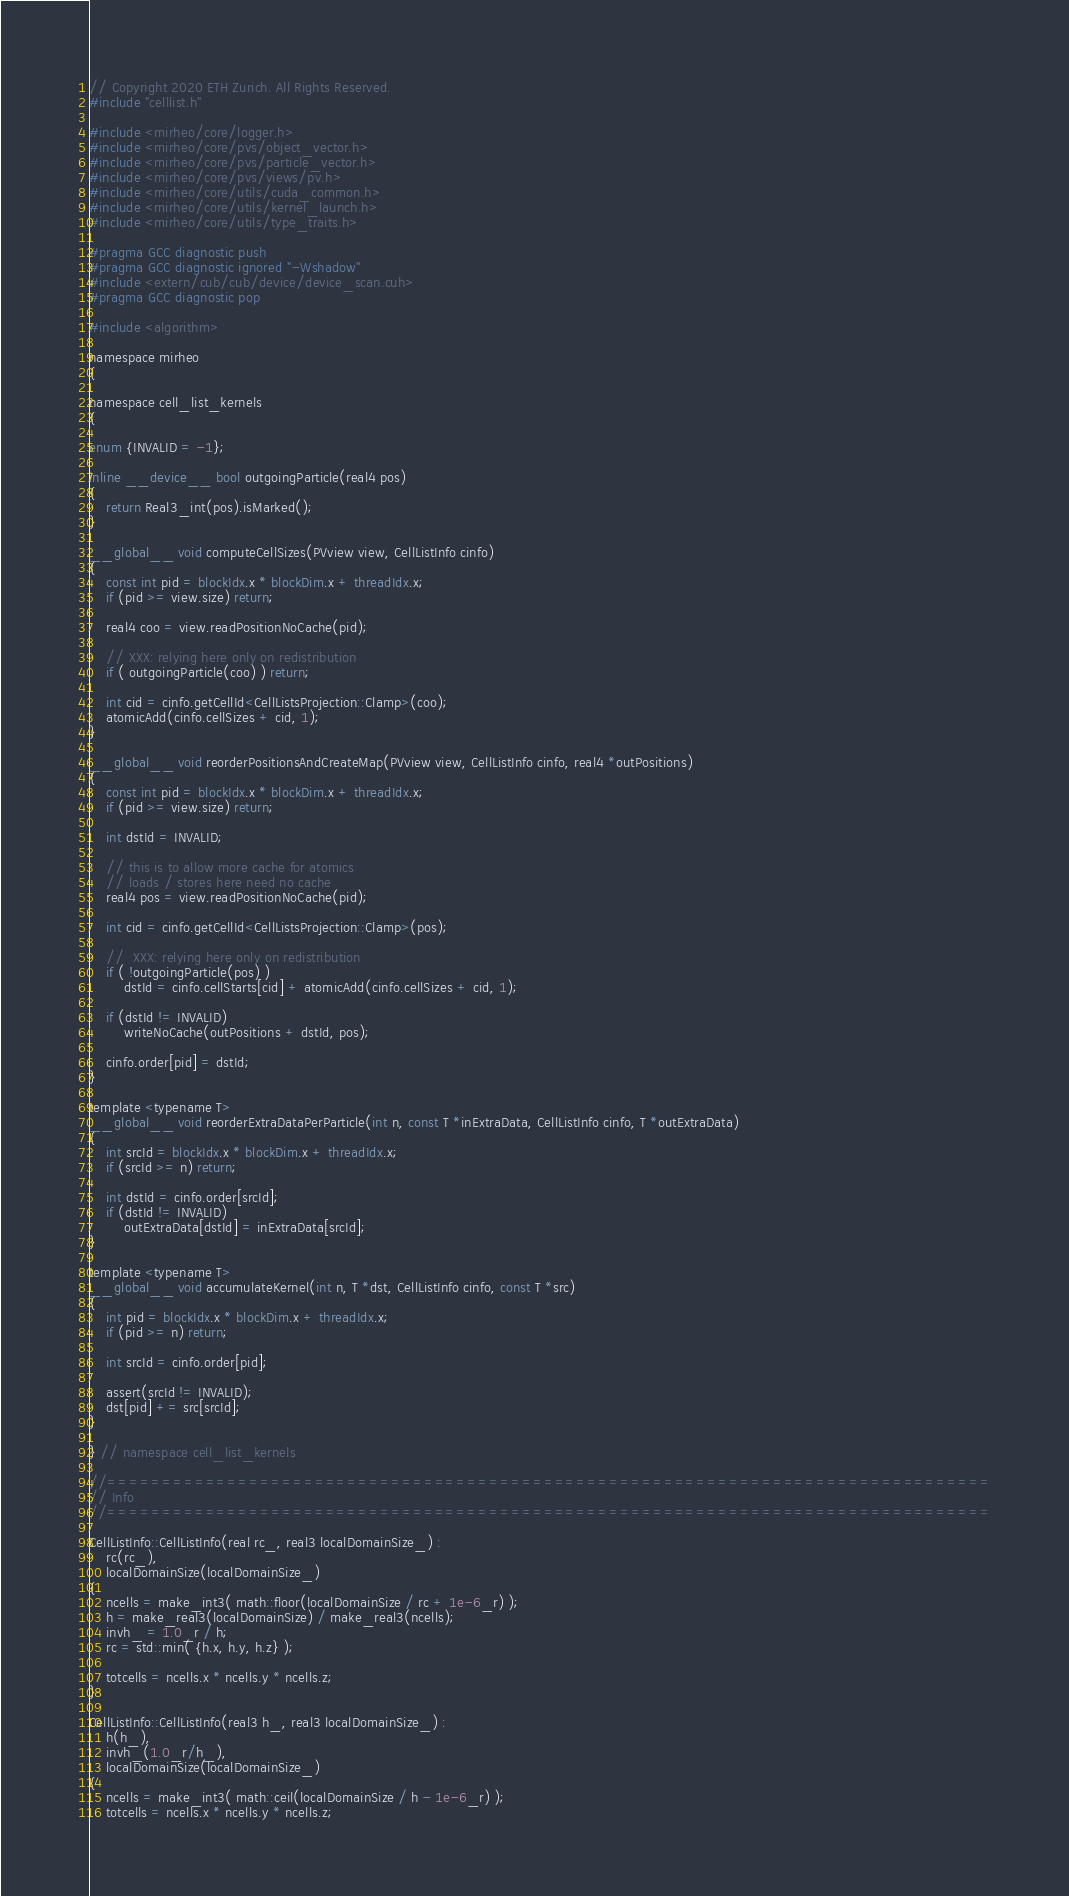<code> <loc_0><loc_0><loc_500><loc_500><_Cuda_>// Copyright 2020 ETH Zurich. All Rights Reserved.
#include "celllist.h"

#include <mirheo/core/logger.h>
#include <mirheo/core/pvs/object_vector.h>
#include <mirheo/core/pvs/particle_vector.h>
#include <mirheo/core/pvs/views/pv.h>
#include <mirheo/core/utils/cuda_common.h>
#include <mirheo/core/utils/kernel_launch.h>
#include <mirheo/core/utils/type_traits.h>

#pragma GCC diagnostic push
#pragma GCC diagnostic ignored "-Wshadow"
#include <extern/cub/cub/device/device_scan.cuh>
#pragma GCC diagnostic pop

#include <algorithm>

namespace mirheo
{

namespace cell_list_kernels
{

enum {INVALID = -1};

inline __device__ bool outgoingParticle(real4 pos)
{
    return Real3_int(pos).isMarked();
}

__global__ void computeCellSizes(PVview view, CellListInfo cinfo)
{
    const int pid = blockIdx.x * blockDim.x + threadIdx.x;
    if (pid >= view.size) return;

    real4 coo = view.readPositionNoCache(pid);

    // XXX: relying here only on redistribution
    if ( outgoingParticle(coo) ) return;

    int cid = cinfo.getCellId<CellListsProjection::Clamp>(coo);
    atomicAdd(cinfo.cellSizes + cid, 1);
}

__global__ void reorderPositionsAndCreateMap(PVview view, CellListInfo cinfo, real4 *outPositions)
{
    const int pid = blockIdx.x * blockDim.x + threadIdx.x;
    if (pid >= view.size) return;

    int dstId = INVALID;

    // this is to allow more cache for atomics
    // loads / stores here need no cache
    real4 pos = view.readPositionNoCache(pid);

    int cid = cinfo.getCellId<CellListsProjection::Clamp>(pos);

    //  XXX: relying here only on redistribution
    if ( !outgoingParticle(pos) )
        dstId = cinfo.cellStarts[cid] + atomicAdd(cinfo.cellSizes + cid, 1);

    if (dstId != INVALID)
        writeNoCache(outPositions + dstId, pos);

    cinfo.order[pid] = dstId;
}

template <typename T>
__global__ void reorderExtraDataPerParticle(int n, const T *inExtraData, CellListInfo cinfo, T *outExtraData)
{
    int srcId = blockIdx.x * blockDim.x + threadIdx.x;
    if (srcId >= n) return;

    int dstId = cinfo.order[srcId];
    if (dstId != INVALID)
        outExtraData[dstId] = inExtraData[srcId];
}

template <typename T>
__global__ void accumulateKernel(int n, T *dst, CellListInfo cinfo, const T *src)
{
    int pid = blockIdx.x * blockDim.x + threadIdx.x;
    if (pid >= n) return;

    int srcId = cinfo.order[pid];

    assert(srcId != INVALID);
    dst[pid] += src[srcId];
}

} // namespace cell_list_kernels

//=================================================================================
// Info
//=================================================================================

CellListInfo::CellListInfo(real rc_, real3 localDomainSize_) :
    rc(rc_),
    localDomainSize(localDomainSize_)
{
    ncells = make_int3( math::floor(localDomainSize / rc + 1e-6_r) );
    h = make_real3(localDomainSize) / make_real3(ncells);
    invh_ = 1.0_r / h;
    rc = std::min( {h.x, h.y, h.z} );

    totcells = ncells.x * ncells.y * ncells.z;
}

CellListInfo::CellListInfo(real3 h_, real3 localDomainSize_) :
    h(h_),
    invh_(1.0_r/h_),
    localDomainSize(localDomainSize_)
{
    ncells = make_int3( math::ceil(localDomainSize / h - 1e-6_r) );
    totcells = ncells.x * ncells.y * ncells.z;</code> 